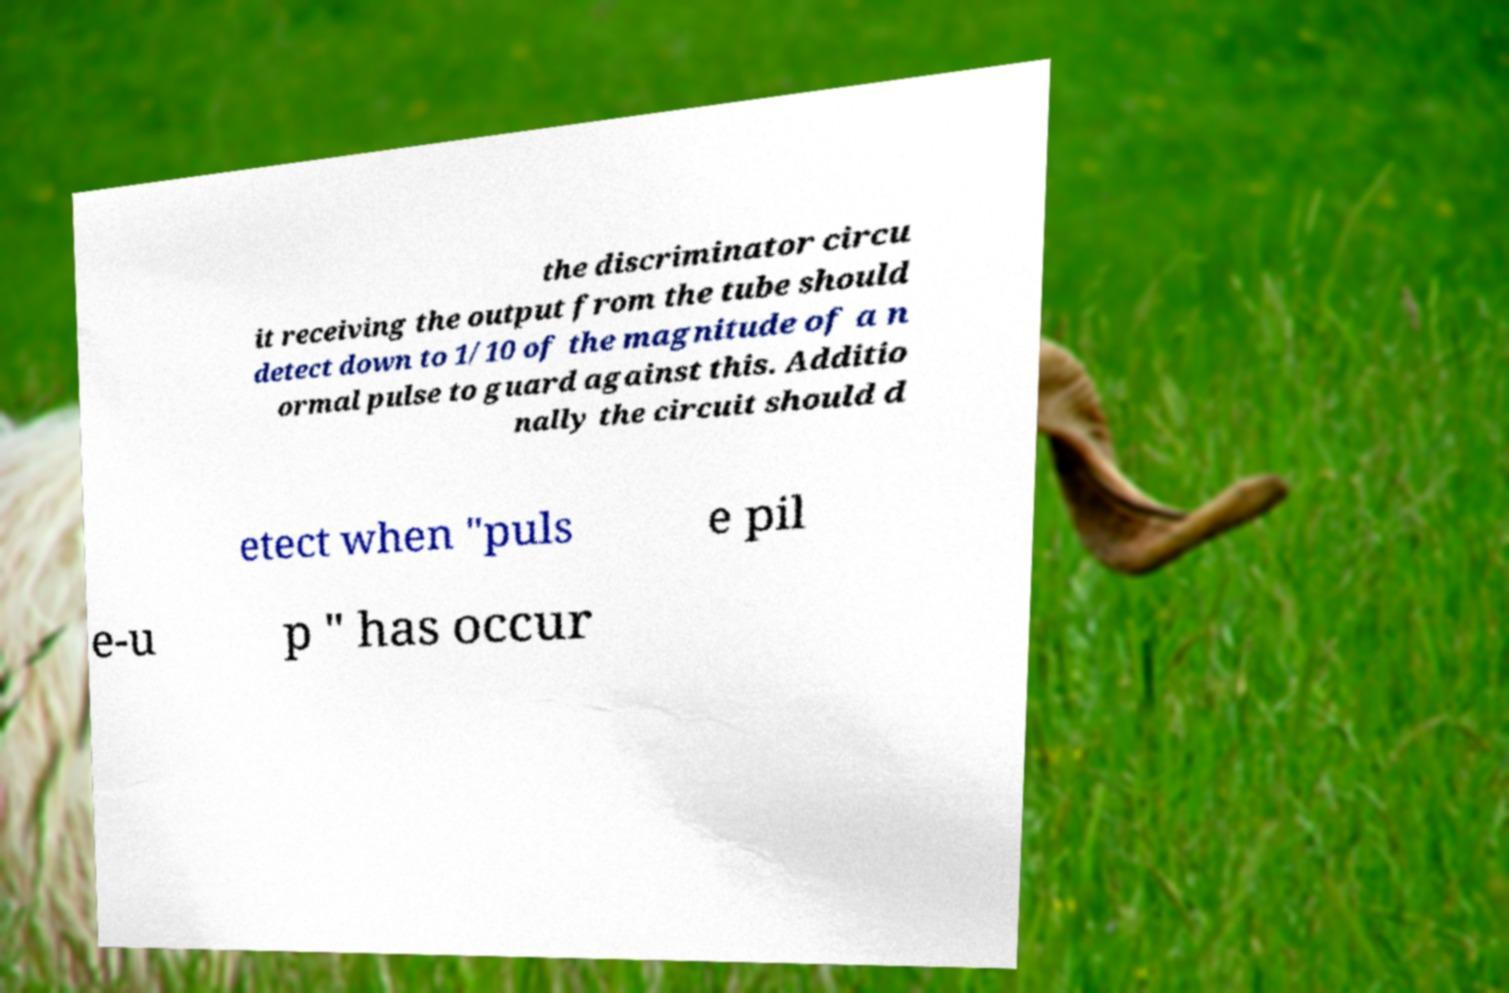There's text embedded in this image that I need extracted. Can you transcribe it verbatim? the discriminator circu it receiving the output from the tube should detect down to 1/10 of the magnitude of a n ormal pulse to guard against this. Additio nally the circuit should d etect when "puls e pil e-u p " has occur 